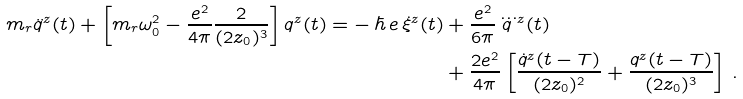<formula> <loc_0><loc_0><loc_500><loc_500>m _ { r } \ddot { q } ^ { z } ( t ) + \left [ m _ { r } \omega ^ { 2 } _ { 0 } - \frac { e ^ { 2 } } { 4 \pi } \frac { 2 } { ( 2 z _ { 0 } ) ^ { 3 } } \right ] q ^ { z } ( t ) = - \, \hbar { \, } e \, \dot { \xi } ^ { z } ( t ) & + \frac { e ^ { 2 } } { 6 \pi } \dddot { q } ^ { z } ( t ) \\ & + \frac { 2 e ^ { 2 } } { 4 \pi } \left [ \frac { \dot { q } ^ { z } ( t - T ) } { ( 2 z _ { 0 } ) ^ { 2 } } + \frac { q ^ { z } ( t - T ) } { ( 2 z _ { 0 } ) ^ { 3 } } \right ] \, .</formula> 